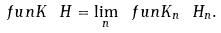<formula> <loc_0><loc_0><loc_500><loc_500>\ f u n { K \ H } = \lim _ { n } \ f u n { K _ { n } \ H _ { n } } .</formula> 